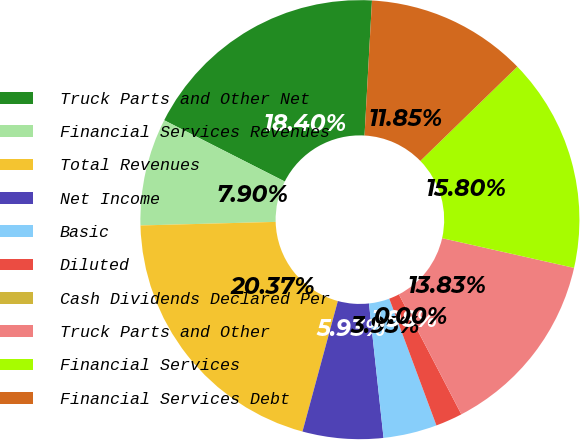<chart> <loc_0><loc_0><loc_500><loc_500><pie_chart><fcel>Truck Parts and Other Net<fcel>Financial Services Revenues<fcel>Total Revenues<fcel>Net Income<fcel>Basic<fcel>Diluted<fcel>Cash Dividends Declared Per<fcel>Truck Parts and Other<fcel>Financial Services<fcel>Financial Services Debt<nl><fcel>18.4%<fcel>7.9%<fcel>20.37%<fcel>5.93%<fcel>3.95%<fcel>1.98%<fcel>0.0%<fcel>13.83%<fcel>15.8%<fcel>11.85%<nl></chart> 